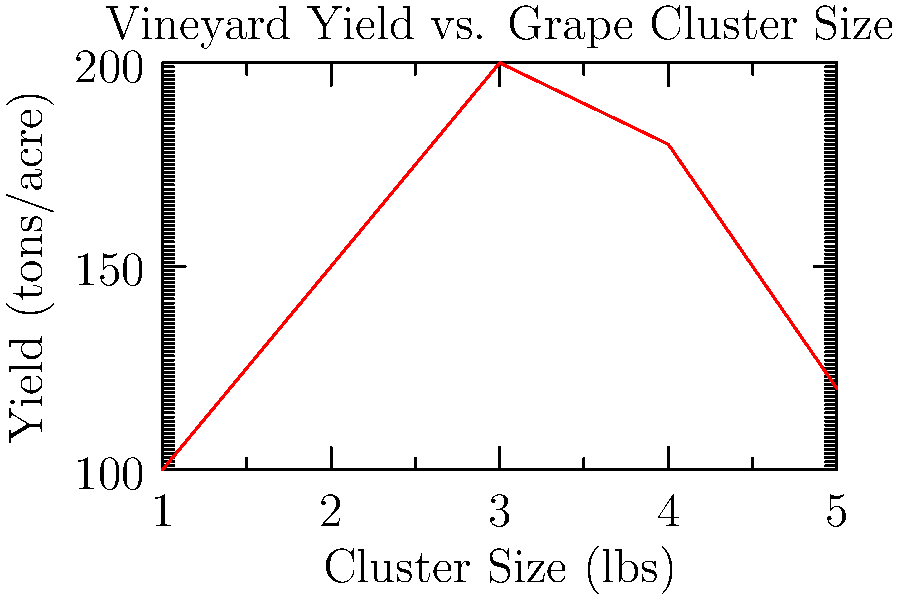Based on the graph showing the relationship between grape cluster size and vineyard yield, at what cluster size (in lbs) does the vineyard achieve its maximum yield? To determine the cluster size that produces the maximum yield, we need to follow these steps:

1. Examine the graph carefully, focusing on the relationship between cluster size (x-axis) and yield (y-axis).
2. Identify the highest point on the curve, which represents the maximum yield.
3. From this highest point, draw an imaginary vertical line down to the x-axis.
4. Read the value on the x-axis where this imaginary line intersects.

Looking at the graph, we can see that the curve peaks at the third data point. This peak corresponds to the highest yield on the y-axis.

Drawing an imaginary vertical line down from this peak, we find that it intersects the x-axis at 3 lbs.

Therefore, the cluster size that produces the maximum yield is 3 lbs.
Answer: 3 lbs 